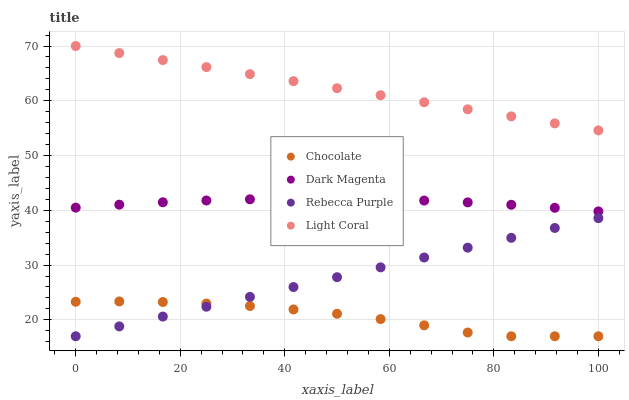Does Chocolate have the minimum area under the curve?
Answer yes or no. Yes. Does Light Coral have the maximum area under the curve?
Answer yes or no. Yes. Does Dark Magenta have the minimum area under the curve?
Answer yes or no. No. Does Dark Magenta have the maximum area under the curve?
Answer yes or no. No. Is Rebecca Purple the smoothest?
Answer yes or no. Yes. Is Chocolate the roughest?
Answer yes or no. Yes. Is Dark Magenta the smoothest?
Answer yes or no. No. Is Dark Magenta the roughest?
Answer yes or no. No. Does Rebecca Purple have the lowest value?
Answer yes or no. Yes. Does Dark Magenta have the lowest value?
Answer yes or no. No. Does Light Coral have the highest value?
Answer yes or no. Yes. Does Dark Magenta have the highest value?
Answer yes or no. No. Is Rebecca Purple less than Light Coral?
Answer yes or no. Yes. Is Dark Magenta greater than Chocolate?
Answer yes or no. Yes. Does Rebecca Purple intersect Chocolate?
Answer yes or no. Yes. Is Rebecca Purple less than Chocolate?
Answer yes or no. No. Is Rebecca Purple greater than Chocolate?
Answer yes or no. No. Does Rebecca Purple intersect Light Coral?
Answer yes or no. No. 